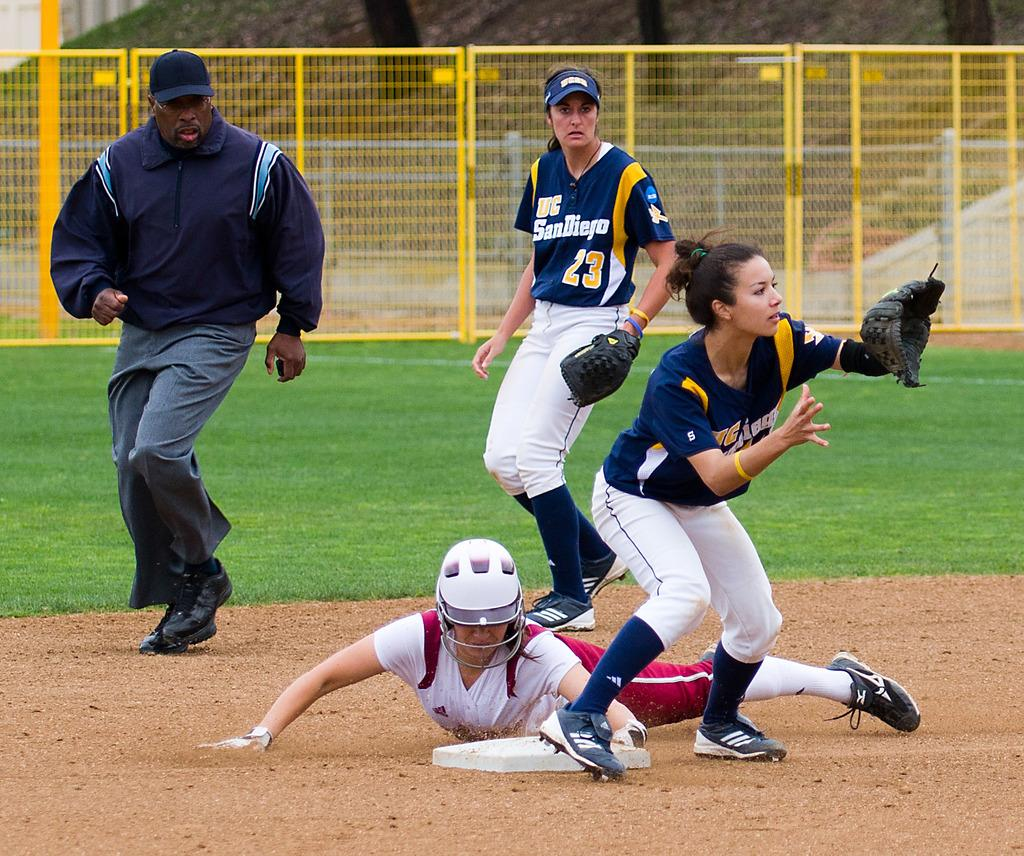<image>
Create a compact narrative representing the image presented. Several softball players during a play, two of which play for UC San Diego. 